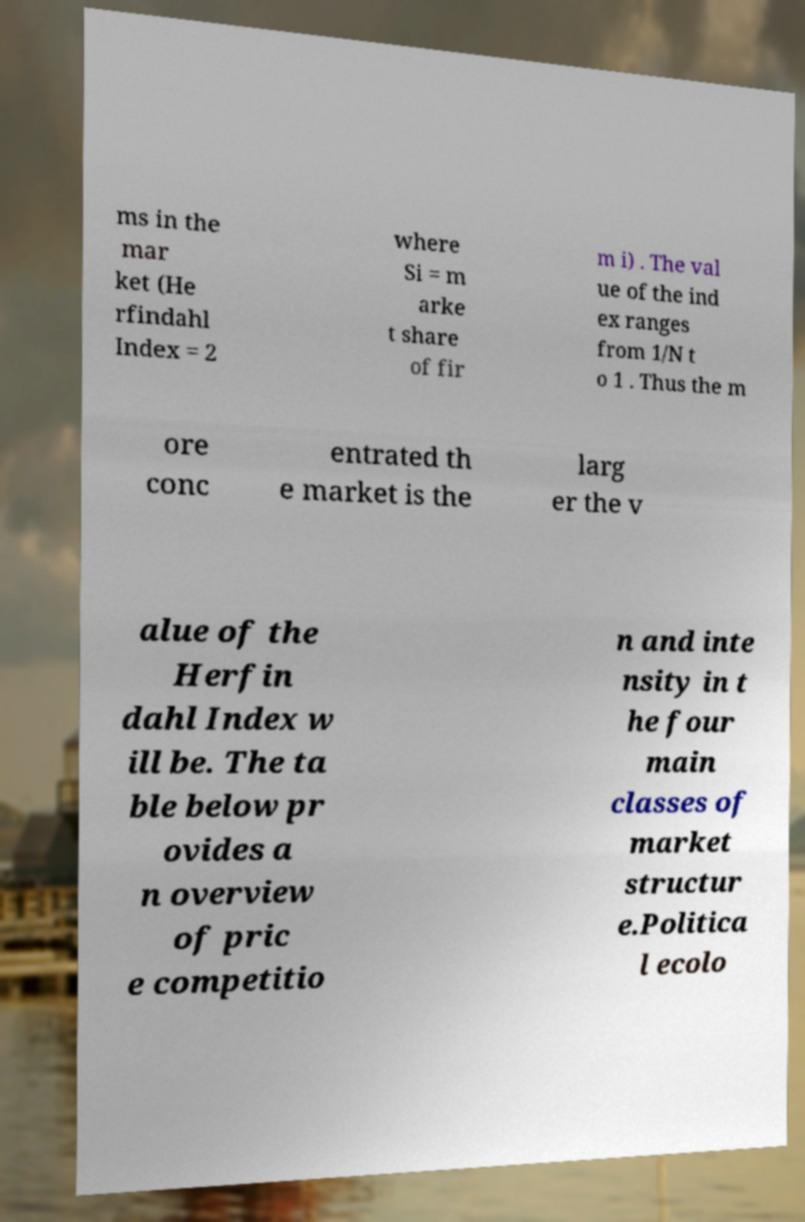Can you accurately transcribe the text from the provided image for me? ms in the mar ket (He rfindahl Index = 2 where Si = m arke t share of fir m i) . The val ue of the ind ex ranges from 1/N t o 1 . Thus the m ore conc entrated th e market is the larg er the v alue of the Herfin dahl Index w ill be. The ta ble below pr ovides a n overview of pric e competitio n and inte nsity in t he four main classes of market structur e.Politica l ecolo 